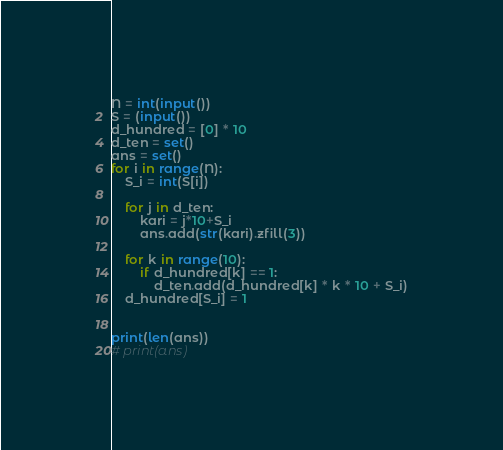<code> <loc_0><loc_0><loc_500><loc_500><_Python_>N = int(input())
S = (input())
d_hundred = [0] * 10
d_ten = set()
ans = set()
for i in range(N):
    S_i = int(S[i])

    for j in d_ten:
        kari = j*10+S_i
        ans.add(str(kari).zfill(3))

    for k in range(10):
        if d_hundred[k] == 1:
            d_ten.add(d_hundred[k] * k * 10 + S_i)
    d_hundred[S_i] = 1


print(len(ans))
# print(ans)
</code> 